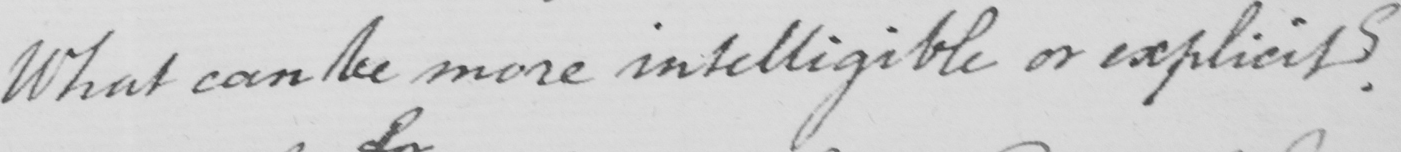Transcribe the text shown in this historical manuscript line. What can be more intelligible or explicit ? 